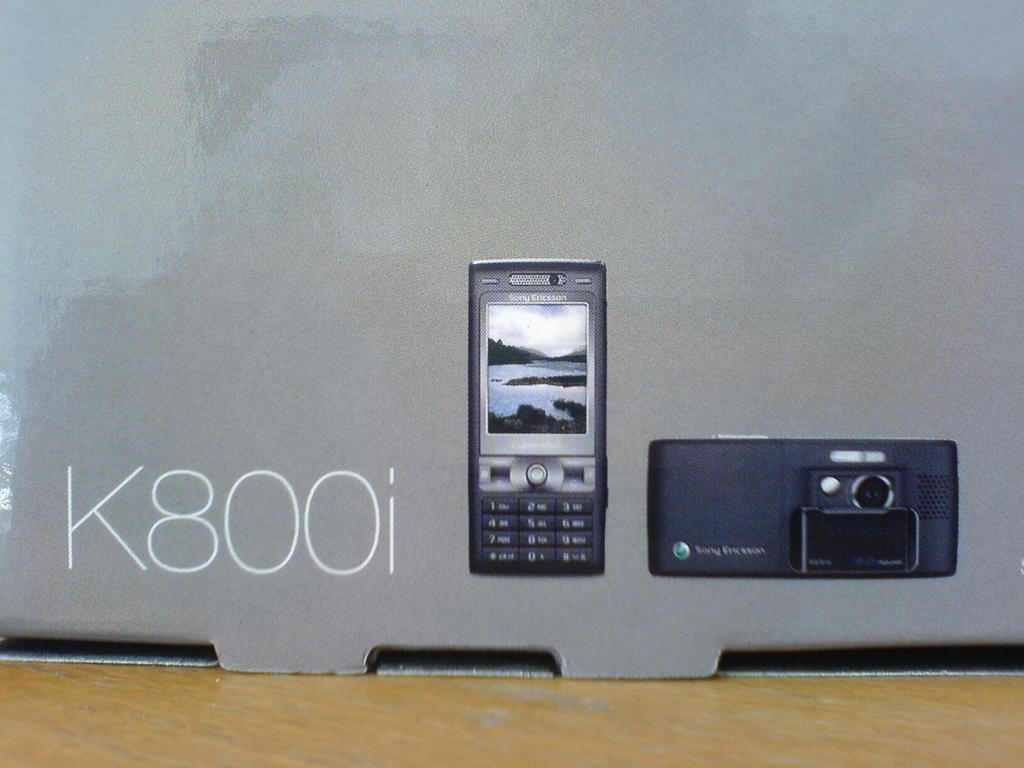What model phone is this?
Offer a very short reply. K800i. 